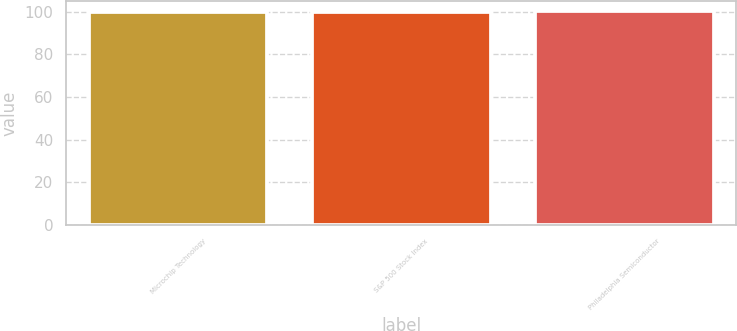<chart> <loc_0><loc_0><loc_500><loc_500><bar_chart><fcel>Microchip Technology<fcel>S&P 500 Stock Index<fcel>Philadelphia Semiconductor<nl><fcel>100<fcel>100.1<fcel>100.2<nl></chart> 